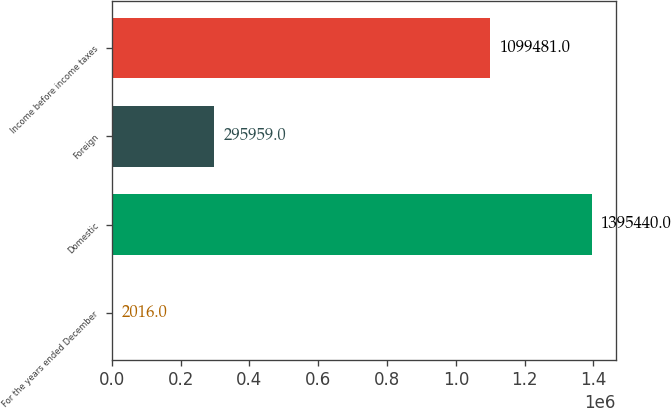<chart> <loc_0><loc_0><loc_500><loc_500><bar_chart><fcel>For the years ended December<fcel>Domestic<fcel>Foreign<fcel>Income before income taxes<nl><fcel>2016<fcel>1.39544e+06<fcel>295959<fcel>1.09948e+06<nl></chart> 